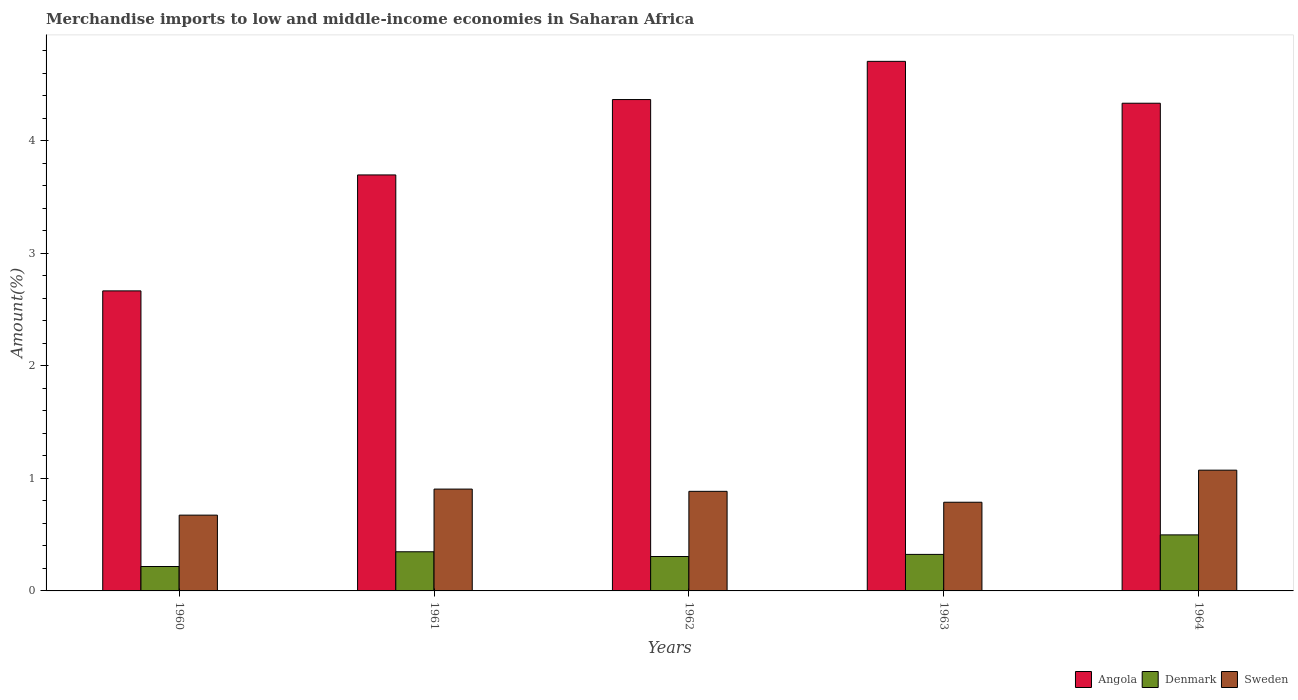Are the number of bars per tick equal to the number of legend labels?
Your response must be concise. Yes. How many bars are there on the 5th tick from the left?
Your answer should be compact. 3. How many bars are there on the 3rd tick from the right?
Give a very brief answer. 3. What is the label of the 2nd group of bars from the left?
Offer a terse response. 1961. What is the percentage of amount earned from merchandise imports in Angola in 1963?
Ensure brevity in your answer.  4.71. Across all years, what is the maximum percentage of amount earned from merchandise imports in Angola?
Offer a terse response. 4.71. Across all years, what is the minimum percentage of amount earned from merchandise imports in Angola?
Provide a succinct answer. 2.67. In which year was the percentage of amount earned from merchandise imports in Angola minimum?
Provide a succinct answer. 1960. What is the total percentage of amount earned from merchandise imports in Angola in the graph?
Offer a terse response. 19.77. What is the difference between the percentage of amount earned from merchandise imports in Sweden in 1962 and that in 1963?
Make the answer very short. 0.1. What is the difference between the percentage of amount earned from merchandise imports in Angola in 1962 and the percentage of amount earned from merchandise imports in Denmark in 1960?
Provide a short and direct response. 4.15. What is the average percentage of amount earned from merchandise imports in Angola per year?
Make the answer very short. 3.95. In the year 1960, what is the difference between the percentage of amount earned from merchandise imports in Denmark and percentage of amount earned from merchandise imports in Angola?
Your response must be concise. -2.45. What is the ratio of the percentage of amount earned from merchandise imports in Angola in 1961 to that in 1964?
Make the answer very short. 0.85. Is the percentage of amount earned from merchandise imports in Angola in 1960 less than that in 1961?
Keep it short and to the point. Yes. Is the difference between the percentage of amount earned from merchandise imports in Denmark in 1960 and 1961 greater than the difference between the percentage of amount earned from merchandise imports in Angola in 1960 and 1961?
Provide a succinct answer. Yes. What is the difference between the highest and the second highest percentage of amount earned from merchandise imports in Sweden?
Provide a short and direct response. 0.17. What is the difference between the highest and the lowest percentage of amount earned from merchandise imports in Sweden?
Offer a terse response. 0.4. Is the sum of the percentage of amount earned from merchandise imports in Sweden in 1961 and 1963 greater than the maximum percentage of amount earned from merchandise imports in Denmark across all years?
Ensure brevity in your answer.  Yes. What does the 2nd bar from the left in 1960 represents?
Your answer should be very brief. Denmark. What does the 3rd bar from the right in 1960 represents?
Give a very brief answer. Angola. Is it the case that in every year, the sum of the percentage of amount earned from merchandise imports in Sweden and percentage of amount earned from merchandise imports in Angola is greater than the percentage of amount earned from merchandise imports in Denmark?
Keep it short and to the point. Yes. Are the values on the major ticks of Y-axis written in scientific E-notation?
Offer a terse response. No. Where does the legend appear in the graph?
Your answer should be very brief. Bottom right. How many legend labels are there?
Make the answer very short. 3. How are the legend labels stacked?
Provide a short and direct response. Horizontal. What is the title of the graph?
Provide a succinct answer. Merchandise imports to low and middle-income economies in Saharan Africa. Does "Norway" appear as one of the legend labels in the graph?
Your answer should be compact. No. What is the label or title of the Y-axis?
Give a very brief answer. Amount(%). What is the Amount(%) of Angola in 1960?
Provide a short and direct response. 2.67. What is the Amount(%) of Denmark in 1960?
Keep it short and to the point. 0.22. What is the Amount(%) in Sweden in 1960?
Your answer should be compact. 0.67. What is the Amount(%) of Angola in 1961?
Your answer should be compact. 3.7. What is the Amount(%) of Denmark in 1961?
Make the answer very short. 0.35. What is the Amount(%) of Sweden in 1961?
Your answer should be compact. 0.91. What is the Amount(%) in Angola in 1962?
Your answer should be compact. 4.37. What is the Amount(%) of Denmark in 1962?
Provide a succinct answer. 0.31. What is the Amount(%) in Sweden in 1962?
Your answer should be compact. 0.89. What is the Amount(%) in Angola in 1963?
Provide a short and direct response. 4.71. What is the Amount(%) in Denmark in 1963?
Give a very brief answer. 0.32. What is the Amount(%) of Sweden in 1963?
Your answer should be compact. 0.79. What is the Amount(%) in Angola in 1964?
Offer a terse response. 4.33. What is the Amount(%) of Denmark in 1964?
Your answer should be very brief. 0.5. What is the Amount(%) of Sweden in 1964?
Provide a short and direct response. 1.07. Across all years, what is the maximum Amount(%) in Angola?
Provide a succinct answer. 4.71. Across all years, what is the maximum Amount(%) of Denmark?
Your response must be concise. 0.5. Across all years, what is the maximum Amount(%) of Sweden?
Your answer should be compact. 1.07. Across all years, what is the minimum Amount(%) of Angola?
Provide a succinct answer. 2.67. Across all years, what is the minimum Amount(%) of Denmark?
Give a very brief answer. 0.22. Across all years, what is the minimum Amount(%) of Sweden?
Offer a terse response. 0.67. What is the total Amount(%) of Angola in the graph?
Your answer should be very brief. 19.77. What is the total Amount(%) in Denmark in the graph?
Your answer should be very brief. 1.69. What is the total Amount(%) of Sweden in the graph?
Your answer should be compact. 4.33. What is the difference between the Amount(%) of Angola in 1960 and that in 1961?
Give a very brief answer. -1.03. What is the difference between the Amount(%) in Denmark in 1960 and that in 1961?
Your answer should be very brief. -0.13. What is the difference between the Amount(%) in Sweden in 1960 and that in 1961?
Your response must be concise. -0.23. What is the difference between the Amount(%) in Angola in 1960 and that in 1962?
Ensure brevity in your answer.  -1.7. What is the difference between the Amount(%) of Denmark in 1960 and that in 1962?
Your answer should be very brief. -0.09. What is the difference between the Amount(%) in Sweden in 1960 and that in 1962?
Keep it short and to the point. -0.21. What is the difference between the Amount(%) of Angola in 1960 and that in 1963?
Ensure brevity in your answer.  -2.04. What is the difference between the Amount(%) of Denmark in 1960 and that in 1963?
Keep it short and to the point. -0.11. What is the difference between the Amount(%) in Sweden in 1960 and that in 1963?
Offer a very short reply. -0.11. What is the difference between the Amount(%) in Angola in 1960 and that in 1964?
Your answer should be compact. -1.67. What is the difference between the Amount(%) of Denmark in 1960 and that in 1964?
Your response must be concise. -0.28. What is the difference between the Amount(%) of Sweden in 1960 and that in 1964?
Your answer should be very brief. -0.4. What is the difference between the Amount(%) in Angola in 1961 and that in 1962?
Make the answer very short. -0.67. What is the difference between the Amount(%) of Denmark in 1961 and that in 1962?
Offer a terse response. 0.04. What is the difference between the Amount(%) in Sweden in 1961 and that in 1962?
Offer a very short reply. 0.02. What is the difference between the Amount(%) in Angola in 1961 and that in 1963?
Provide a short and direct response. -1.01. What is the difference between the Amount(%) of Denmark in 1961 and that in 1963?
Provide a short and direct response. 0.02. What is the difference between the Amount(%) of Sweden in 1961 and that in 1963?
Ensure brevity in your answer.  0.12. What is the difference between the Amount(%) in Angola in 1961 and that in 1964?
Your response must be concise. -0.64. What is the difference between the Amount(%) of Denmark in 1961 and that in 1964?
Your answer should be compact. -0.15. What is the difference between the Amount(%) in Sweden in 1961 and that in 1964?
Offer a very short reply. -0.17. What is the difference between the Amount(%) in Angola in 1962 and that in 1963?
Give a very brief answer. -0.34. What is the difference between the Amount(%) of Denmark in 1962 and that in 1963?
Your answer should be very brief. -0.02. What is the difference between the Amount(%) in Sweden in 1962 and that in 1963?
Provide a succinct answer. 0.1. What is the difference between the Amount(%) in Angola in 1962 and that in 1964?
Ensure brevity in your answer.  0.03. What is the difference between the Amount(%) of Denmark in 1962 and that in 1964?
Offer a terse response. -0.19. What is the difference between the Amount(%) of Sweden in 1962 and that in 1964?
Ensure brevity in your answer.  -0.19. What is the difference between the Amount(%) of Angola in 1963 and that in 1964?
Make the answer very short. 0.37. What is the difference between the Amount(%) of Denmark in 1963 and that in 1964?
Make the answer very short. -0.17. What is the difference between the Amount(%) in Sweden in 1963 and that in 1964?
Keep it short and to the point. -0.29. What is the difference between the Amount(%) of Angola in 1960 and the Amount(%) of Denmark in 1961?
Your answer should be very brief. 2.32. What is the difference between the Amount(%) in Angola in 1960 and the Amount(%) in Sweden in 1961?
Make the answer very short. 1.76. What is the difference between the Amount(%) in Denmark in 1960 and the Amount(%) in Sweden in 1961?
Keep it short and to the point. -0.69. What is the difference between the Amount(%) in Angola in 1960 and the Amount(%) in Denmark in 1962?
Make the answer very short. 2.36. What is the difference between the Amount(%) of Angola in 1960 and the Amount(%) of Sweden in 1962?
Offer a very short reply. 1.78. What is the difference between the Amount(%) in Denmark in 1960 and the Amount(%) in Sweden in 1962?
Provide a short and direct response. -0.67. What is the difference between the Amount(%) in Angola in 1960 and the Amount(%) in Denmark in 1963?
Make the answer very short. 2.34. What is the difference between the Amount(%) in Angola in 1960 and the Amount(%) in Sweden in 1963?
Offer a terse response. 1.88. What is the difference between the Amount(%) in Denmark in 1960 and the Amount(%) in Sweden in 1963?
Keep it short and to the point. -0.57. What is the difference between the Amount(%) of Angola in 1960 and the Amount(%) of Denmark in 1964?
Provide a short and direct response. 2.17. What is the difference between the Amount(%) in Angola in 1960 and the Amount(%) in Sweden in 1964?
Offer a very short reply. 1.59. What is the difference between the Amount(%) in Denmark in 1960 and the Amount(%) in Sweden in 1964?
Give a very brief answer. -0.86. What is the difference between the Amount(%) in Angola in 1961 and the Amount(%) in Denmark in 1962?
Make the answer very short. 3.39. What is the difference between the Amount(%) of Angola in 1961 and the Amount(%) of Sweden in 1962?
Provide a succinct answer. 2.81. What is the difference between the Amount(%) in Denmark in 1961 and the Amount(%) in Sweden in 1962?
Your answer should be compact. -0.54. What is the difference between the Amount(%) of Angola in 1961 and the Amount(%) of Denmark in 1963?
Your answer should be very brief. 3.37. What is the difference between the Amount(%) in Angola in 1961 and the Amount(%) in Sweden in 1963?
Ensure brevity in your answer.  2.91. What is the difference between the Amount(%) in Denmark in 1961 and the Amount(%) in Sweden in 1963?
Make the answer very short. -0.44. What is the difference between the Amount(%) in Angola in 1961 and the Amount(%) in Denmark in 1964?
Ensure brevity in your answer.  3.2. What is the difference between the Amount(%) in Angola in 1961 and the Amount(%) in Sweden in 1964?
Keep it short and to the point. 2.62. What is the difference between the Amount(%) in Denmark in 1961 and the Amount(%) in Sweden in 1964?
Offer a terse response. -0.73. What is the difference between the Amount(%) of Angola in 1962 and the Amount(%) of Denmark in 1963?
Offer a terse response. 4.04. What is the difference between the Amount(%) of Angola in 1962 and the Amount(%) of Sweden in 1963?
Offer a terse response. 3.58. What is the difference between the Amount(%) in Denmark in 1962 and the Amount(%) in Sweden in 1963?
Your answer should be compact. -0.48. What is the difference between the Amount(%) in Angola in 1962 and the Amount(%) in Denmark in 1964?
Ensure brevity in your answer.  3.87. What is the difference between the Amount(%) of Angola in 1962 and the Amount(%) of Sweden in 1964?
Your response must be concise. 3.29. What is the difference between the Amount(%) of Denmark in 1962 and the Amount(%) of Sweden in 1964?
Offer a terse response. -0.77. What is the difference between the Amount(%) in Angola in 1963 and the Amount(%) in Denmark in 1964?
Offer a terse response. 4.21. What is the difference between the Amount(%) in Angola in 1963 and the Amount(%) in Sweden in 1964?
Your answer should be compact. 3.63. What is the difference between the Amount(%) of Denmark in 1963 and the Amount(%) of Sweden in 1964?
Keep it short and to the point. -0.75. What is the average Amount(%) of Angola per year?
Give a very brief answer. 3.95. What is the average Amount(%) of Denmark per year?
Keep it short and to the point. 0.34. What is the average Amount(%) of Sweden per year?
Provide a succinct answer. 0.86. In the year 1960, what is the difference between the Amount(%) of Angola and Amount(%) of Denmark?
Your answer should be compact. 2.45. In the year 1960, what is the difference between the Amount(%) of Angola and Amount(%) of Sweden?
Offer a terse response. 1.99. In the year 1960, what is the difference between the Amount(%) of Denmark and Amount(%) of Sweden?
Provide a short and direct response. -0.46. In the year 1961, what is the difference between the Amount(%) in Angola and Amount(%) in Denmark?
Ensure brevity in your answer.  3.35. In the year 1961, what is the difference between the Amount(%) in Angola and Amount(%) in Sweden?
Offer a very short reply. 2.79. In the year 1961, what is the difference between the Amount(%) in Denmark and Amount(%) in Sweden?
Your response must be concise. -0.56. In the year 1962, what is the difference between the Amount(%) of Angola and Amount(%) of Denmark?
Ensure brevity in your answer.  4.06. In the year 1962, what is the difference between the Amount(%) in Angola and Amount(%) in Sweden?
Keep it short and to the point. 3.48. In the year 1962, what is the difference between the Amount(%) in Denmark and Amount(%) in Sweden?
Your response must be concise. -0.58. In the year 1963, what is the difference between the Amount(%) in Angola and Amount(%) in Denmark?
Provide a short and direct response. 4.38. In the year 1963, what is the difference between the Amount(%) in Angola and Amount(%) in Sweden?
Provide a succinct answer. 3.92. In the year 1963, what is the difference between the Amount(%) of Denmark and Amount(%) of Sweden?
Provide a succinct answer. -0.46. In the year 1964, what is the difference between the Amount(%) of Angola and Amount(%) of Denmark?
Your answer should be compact. 3.84. In the year 1964, what is the difference between the Amount(%) of Angola and Amount(%) of Sweden?
Your response must be concise. 3.26. In the year 1964, what is the difference between the Amount(%) of Denmark and Amount(%) of Sweden?
Ensure brevity in your answer.  -0.58. What is the ratio of the Amount(%) in Angola in 1960 to that in 1961?
Keep it short and to the point. 0.72. What is the ratio of the Amount(%) of Denmark in 1960 to that in 1961?
Keep it short and to the point. 0.62. What is the ratio of the Amount(%) in Sweden in 1960 to that in 1961?
Offer a terse response. 0.74. What is the ratio of the Amount(%) in Angola in 1960 to that in 1962?
Your response must be concise. 0.61. What is the ratio of the Amount(%) of Denmark in 1960 to that in 1962?
Your answer should be very brief. 0.71. What is the ratio of the Amount(%) of Sweden in 1960 to that in 1962?
Offer a very short reply. 0.76. What is the ratio of the Amount(%) in Angola in 1960 to that in 1963?
Ensure brevity in your answer.  0.57. What is the ratio of the Amount(%) of Denmark in 1960 to that in 1963?
Make the answer very short. 0.67. What is the ratio of the Amount(%) of Sweden in 1960 to that in 1963?
Your answer should be compact. 0.85. What is the ratio of the Amount(%) in Angola in 1960 to that in 1964?
Provide a short and direct response. 0.62. What is the ratio of the Amount(%) in Denmark in 1960 to that in 1964?
Your answer should be very brief. 0.44. What is the ratio of the Amount(%) in Sweden in 1960 to that in 1964?
Your answer should be very brief. 0.63. What is the ratio of the Amount(%) of Angola in 1961 to that in 1962?
Provide a short and direct response. 0.85. What is the ratio of the Amount(%) in Denmark in 1961 to that in 1962?
Make the answer very short. 1.14. What is the ratio of the Amount(%) in Sweden in 1961 to that in 1962?
Keep it short and to the point. 1.02. What is the ratio of the Amount(%) of Angola in 1961 to that in 1963?
Give a very brief answer. 0.79. What is the ratio of the Amount(%) of Denmark in 1961 to that in 1963?
Make the answer very short. 1.07. What is the ratio of the Amount(%) of Sweden in 1961 to that in 1963?
Make the answer very short. 1.15. What is the ratio of the Amount(%) in Angola in 1961 to that in 1964?
Make the answer very short. 0.85. What is the ratio of the Amount(%) in Denmark in 1961 to that in 1964?
Provide a short and direct response. 0.7. What is the ratio of the Amount(%) of Sweden in 1961 to that in 1964?
Give a very brief answer. 0.84. What is the ratio of the Amount(%) in Angola in 1962 to that in 1963?
Make the answer very short. 0.93. What is the ratio of the Amount(%) in Denmark in 1962 to that in 1963?
Your answer should be compact. 0.94. What is the ratio of the Amount(%) in Sweden in 1962 to that in 1963?
Keep it short and to the point. 1.12. What is the ratio of the Amount(%) of Angola in 1962 to that in 1964?
Ensure brevity in your answer.  1.01. What is the ratio of the Amount(%) of Denmark in 1962 to that in 1964?
Ensure brevity in your answer.  0.61. What is the ratio of the Amount(%) of Sweden in 1962 to that in 1964?
Keep it short and to the point. 0.82. What is the ratio of the Amount(%) in Angola in 1963 to that in 1964?
Your answer should be very brief. 1.09. What is the ratio of the Amount(%) in Denmark in 1963 to that in 1964?
Ensure brevity in your answer.  0.65. What is the ratio of the Amount(%) of Sweden in 1963 to that in 1964?
Offer a very short reply. 0.73. What is the difference between the highest and the second highest Amount(%) in Angola?
Your response must be concise. 0.34. What is the difference between the highest and the second highest Amount(%) of Denmark?
Provide a succinct answer. 0.15. What is the difference between the highest and the second highest Amount(%) in Sweden?
Provide a short and direct response. 0.17. What is the difference between the highest and the lowest Amount(%) of Angola?
Provide a succinct answer. 2.04. What is the difference between the highest and the lowest Amount(%) in Denmark?
Your answer should be very brief. 0.28. What is the difference between the highest and the lowest Amount(%) of Sweden?
Ensure brevity in your answer.  0.4. 